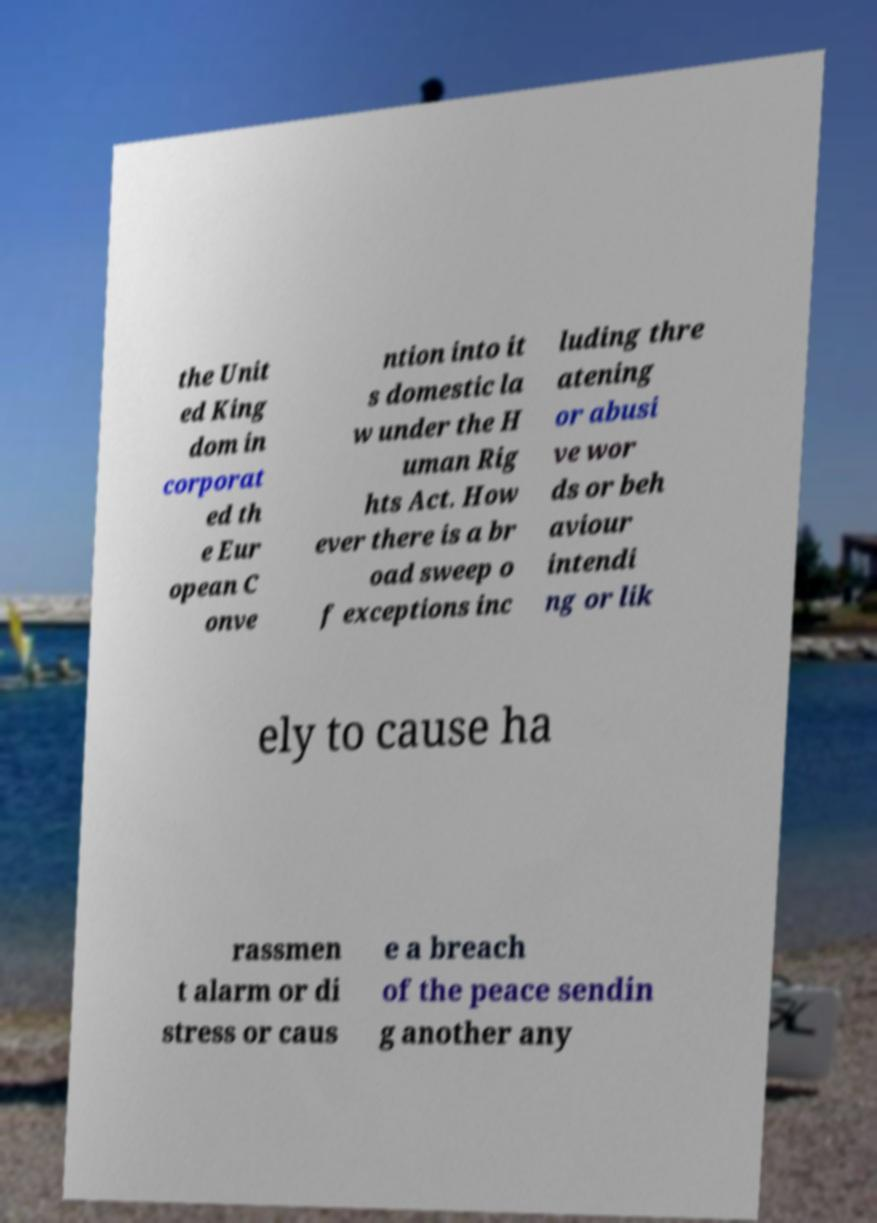Could you assist in decoding the text presented in this image and type it out clearly? the Unit ed King dom in corporat ed th e Eur opean C onve ntion into it s domestic la w under the H uman Rig hts Act. How ever there is a br oad sweep o f exceptions inc luding thre atening or abusi ve wor ds or beh aviour intendi ng or lik ely to cause ha rassmen t alarm or di stress or caus e a breach of the peace sendin g another any 